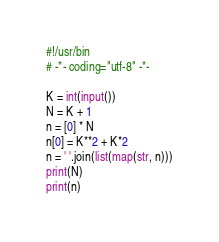Convert code to text. <code><loc_0><loc_0><loc_500><loc_500><_Python_>#!/usr/bin
# -*- coding="utf-8" -*-
 
K = int(input())
N = K + 1
n = [0] * N
n[0] = K**2 + K*2
n = ' '.join(list(map(str, n)))
print(N)
print(n)
</code> 